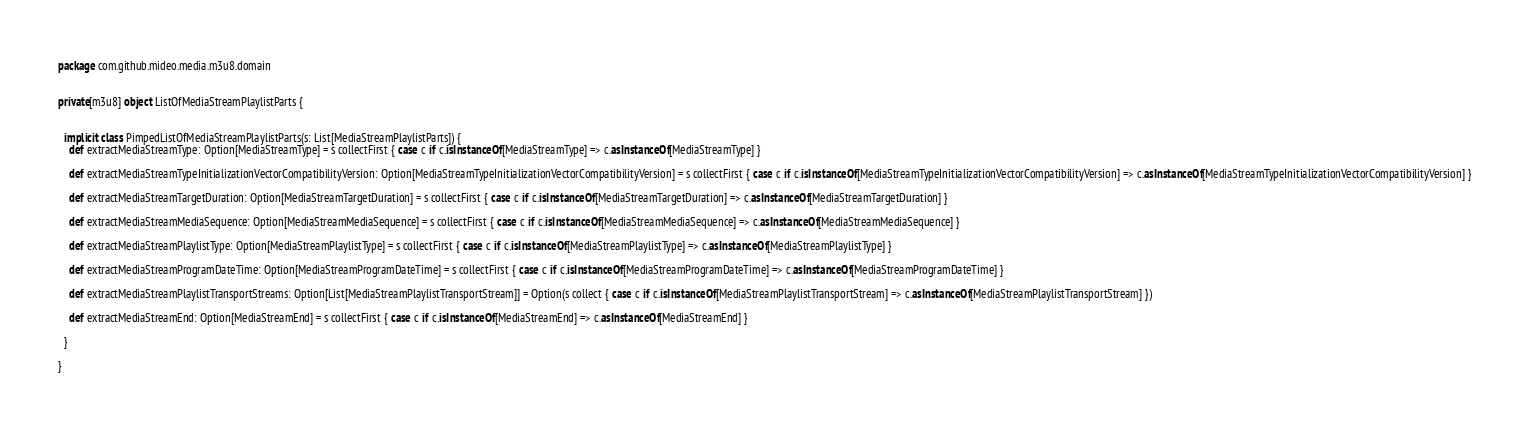<code> <loc_0><loc_0><loc_500><loc_500><_Scala_>package com.github.mideo.media.m3u8.domain


private[m3u8] object ListOfMediaStreamPlaylistParts {


  implicit class PimpedListOfMediaStreamPlaylistParts(s: List[MediaStreamPlaylistParts]) {
    def extractMediaStreamType: Option[MediaStreamType] = s collectFirst { case c if c.isInstanceOf[MediaStreamType] => c.asInstanceOf[MediaStreamType] }

    def extractMediaStreamTypeInitializationVectorCompatibilityVersion: Option[MediaStreamTypeInitializationVectorCompatibilityVersion] = s collectFirst { case c if c.isInstanceOf[MediaStreamTypeInitializationVectorCompatibilityVersion] => c.asInstanceOf[MediaStreamTypeInitializationVectorCompatibilityVersion] }

    def extractMediaStreamTargetDuration: Option[MediaStreamTargetDuration] = s collectFirst { case c if c.isInstanceOf[MediaStreamTargetDuration] => c.asInstanceOf[MediaStreamTargetDuration] }

    def extractMediaStreamMediaSequence: Option[MediaStreamMediaSequence] = s collectFirst { case c if c.isInstanceOf[MediaStreamMediaSequence] => c.asInstanceOf[MediaStreamMediaSequence] }

    def extractMediaStreamPlaylistType: Option[MediaStreamPlaylistType] = s collectFirst { case c if c.isInstanceOf[MediaStreamPlaylistType] => c.asInstanceOf[MediaStreamPlaylistType] }

    def extractMediaStreamProgramDateTime: Option[MediaStreamProgramDateTime] = s collectFirst { case c if c.isInstanceOf[MediaStreamProgramDateTime] => c.asInstanceOf[MediaStreamProgramDateTime] }

    def extractMediaStreamPlaylistTransportStreams: Option[List[MediaStreamPlaylistTransportStream]] = Option(s collect { case c if c.isInstanceOf[MediaStreamPlaylistTransportStream] => c.asInstanceOf[MediaStreamPlaylistTransportStream] })

    def extractMediaStreamEnd: Option[MediaStreamEnd] = s collectFirst { case c if c.isInstanceOf[MediaStreamEnd] => c.asInstanceOf[MediaStreamEnd] }

  }

}
</code> 